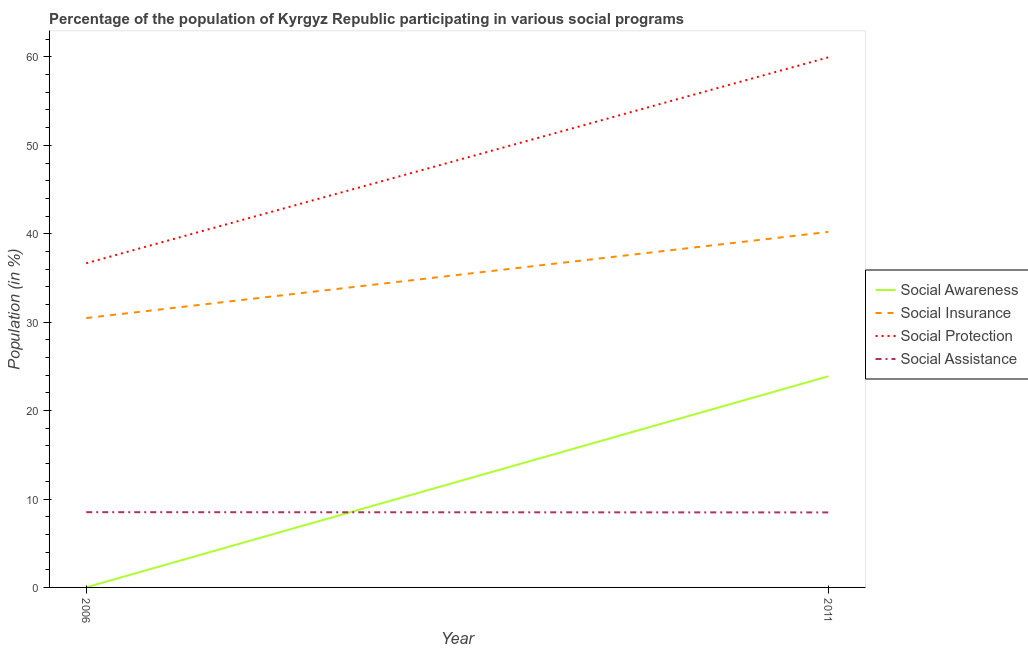How many different coloured lines are there?
Your response must be concise. 4. Does the line corresponding to participation of population in social assistance programs intersect with the line corresponding to participation of population in social protection programs?
Provide a short and direct response. No. What is the participation of population in social awareness programs in 2006?
Ensure brevity in your answer.  0.02. Across all years, what is the maximum participation of population in social insurance programs?
Offer a very short reply. 40.21. Across all years, what is the minimum participation of population in social insurance programs?
Your answer should be very brief. 30.47. In which year was the participation of population in social awareness programs maximum?
Offer a terse response. 2011. What is the total participation of population in social insurance programs in the graph?
Keep it short and to the point. 70.67. What is the difference between the participation of population in social insurance programs in 2006 and that in 2011?
Make the answer very short. -9.74. What is the difference between the participation of population in social insurance programs in 2011 and the participation of population in social awareness programs in 2006?
Your answer should be very brief. 40.19. What is the average participation of population in social assistance programs per year?
Provide a short and direct response. 8.5. In the year 2011, what is the difference between the participation of population in social insurance programs and participation of population in social protection programs?
Make the answer very short. -19.75. In how many years, is the participation of population in social insurance programs greater than 4 %?
Make the answer very short. 2. What is the ratio of the participation of population in social assistance programs in 2006 to that in 2011?
Keep it short and to the point. 1. Is the participation of population in social protection programs in 2006 less than that in 2011?
Provide a succinct answer. Yes. Does the participation of population in social awareness programs monotonically increase over the years?
Your answer should be very brief. Yes. Is the participation of population in social protection programs strictly greater than the participation of population in social insurance programs over the years?
Your answer should be compact. Yes. Is the participation of population in social awareness programs strictly less than the participation of population in social assistance programs over the years?
Give a very brief answer. No. What is the difference between two consecutive major ticks on the Y-axis?
Your answer should be compact. 10. Does the graph contain grids?
Provide a succinct answer. No. Where does the legend appear in the graph?
Make the answer very short. Center right. How are the legend labels stacked?
Ensure brevity in your answer.  Vertical. What is the title of the graph?
Your response must be concise. Percentage of the population of Kyrgyz Republic participating in various social programs . What is the label or title of the Y-axis?
Your response must be concise. Population (in %). What is the Population (in %) of Social Awareness in 2006?
Offer a terse response. 0.02. What is the Population (in %) of Social Insurance in 2006?
Provide a succinct answer. 30.47. What is the Population (in %) of Social Protection in 2006?
Offer a very short reply. 36.66. What is the Population (in %) in Social Assistance in 2006?
Offer a very short reply. 8.51. What is the Population (in %) in Social Awareness in 2011?
Keep it short and to the point. 23.88. What is the Population (in %) in Social Insurance in 2011?
Offer a terse response. 40.21. What is the Population (in %) in Social Protection in 2011?
Give a very brief answer. 59.95. What is the Population (in %) in Social Assistance in 2011?
Your answer should be compact. 8.48. Across all years, what is the maximum Population (in %) of Social Awareness?
Give a very brief answer. 23.88. Across all years, what is the maximum Population (in %) of Social Insurance?
Offer a very short reply. 40.21. Across all years, what is the maximum Population (in %) of Social Protection?
Give a very brief answer. 59.95. Across all years, what is the maximum Population (in %) of Social Assistance?
Provide a succinct answer. 8.51. Across all years, what is the minimum Population (in %) in Social Awareness?
Your answer should be compact. 0.02. Across all years, what is the minimum Population (in %) in Social Insurance?
Give a very brief answer. 30.47. Across all years, what is the minimum Population (in %) of Social Protection?
Ensure brevity in your answer.  36.66. Across all years, what is the minimum Population (in %) in Social Assistance?
Keep it short and to the point. 8.48. What is the total Population (in %) in Social Awareness in the graph?
Your answer should be very brief. 23.9. What is the total Population (in %) in Social Insurance in the graph?
Your answer should be very brief. 70.67. What is the total Population (in %) in Social Protection in the graph?
Provide a succinct answer. 96.62. What is the total Population (in %) in Social Assistance in the graph?
Your answer should be compact. 16.99. What is the difference between the Population (in %) of Social Awareness in 2006 and that in 2011?
Your answer should be very brief. -23.87. What is the difference between the Population (in %) in Social Insurance in 2006 and that in 2011?
Your answer should be compact. -9.74. What is the difference between the Population (in %) of Social Protection in 2006 and that in 2011?
Make the answer very short. -23.29. What is the difference between the Population (in %) in Social Assistance in 2006 and that in 2011?
Give a very brief answer. 0.03. What is the difference between the Population (in %) of Social Awareness in 2006 and the Population (in %) of Social Insurance in 2011?
Your answer should be very brief. -40.19. What is the difference between the Population (in %) in Social Awareness in 2006 and the Population (in %) in Social Protection in 2011?
Provide a short and direct response. -59.94. What is the difference between the Population (in %) in Social Awareness in 2006 and the Population (in %) in Social Assistance in 2011?
Offer a very short reply. -8.47. What is the difference between the Population (in %) of Social Insurance in 2006 and the Population (in %) of Social Protection in 2011?
Your response must be concise. -29.49. What is the difference between the Population (in %) in Social Insurance in 2006 and the Population (in %) in Social Assistance in 2011?
Your response must be concise. 21.98. What is the difference between the Population (in %) in Social Protection in 2006 and the Population (in %) in Social Assistance in 2011?
Offer a terse response. 28.18. What is the average Population (in %) of Social Awareness per year?
Your answer should be very brief. 11.95. What is the average Population (in %) in Social Insurance per year?
Provide a succinct answer. 35.34. What is the average Population (in %) of Social Protection per year?
Offer a terse response. 48.31. What is the average Population (in %) of Social Assistance per year?
Provide a succinct answer. 8.5. In the year 2006, what is the difference between the Population (in %) in Social Awareness and Population (in %) in Social Insurance?
Ensure brevity in your answer.  -30.45. In the year 2006, what is the difference between the Population (in %) in Social Awareness and Population (in %) in Social Protection?
Your response must be concise. -36.65. In the year 2006, what is the difference between the Population (in %) in Social Awareness and Population (in %) in Social Assistance?
Provide a short and direct response. -8.5. In the year 2006, what is the difference between the Population (in %) in Social Insurance and Population (in %) in Social Protection?
Offer a very short reply. -6.2. In the year 2006, what is the difference between the Population (in %) in Social Insurance and Population (in %) in Social Assistance?
Your response must be concise. 21.96. In the year 2006, what is the difference between the Population (in %) in Social Protection and Population (in %) in Social Assistance?
Your answer should be very brief. 28.15. In the year 2011, what is the difference between the Population (in %) of Social Awareness and Population (in %) of Social Insurance?
Your answer should be very brief. -16.33. In the year 2011, what is the difference between the Population (in %) of Social Awareness and Population (in %) of Social Protection?
Your response must be concise. -36.07. In the year 2011, what is the difference between the Population (in %) in Social Awareness and Population (in %) in Social Assistance?
Your response must be concise. 15.4. In the year 2011, what is the difference between the Population (in %) in Social Insurance and Population (in %) in Social Protection?
Provide a short and direct response. -19.75. In the year 2011, what is the difference between the Population (in %) in Social Insurance and Population (in %) in Social Assistance?
Offer a terse response. 31.73. In the year 2011, what is the difference between the Population (in %) of Social Protection and Population (in %) of Social Assistance?
Provide a short and direct response. 51.47. What is the ratio of the Population (in %) in Social Awareness in 2006 to that in 2011?
Provide a short and direct response. 0. What is the ratio of the Population (in %) in Social Insurance in 2006 to that in 2011?
Your response must be concise. 0.76. What is the ratio of the Population (in %) in Social Protection in 2006 to that in 2011?
Your answer should be compact. 0.61. What is the ratio of the Population (in %) in Social Assistance in 2006 to that in 2011?
Keep it short and to the point. 1. What is the difference between the highest and the second highest Population (in %) of Social Awareness?
Your response must be concise. 23.87. What is the difference between the highest and the second highest Population (in %) of Social Insurance?
Provide a short and direct response. 9.74. What is the difference between the highest and the second highest Population (in %) of Social Protection?
Make the answer very short. 23.29. What is the difference between the highest and the second highest Population (in %) in Social Assistance?
Ensure brevity in your answer.  0.03. What is the difference between the highest and the lowest Population (in %) in Social Awareness?
Your response must be concise. 23.87. What is the difference between the highest and the lowest Population (in %) of Social Insurance?
Offer a very short reply. 9.74. What is the difference between the highest and the lowest Population (in %) of Social Protection?
Make the answer very short. 23.29. What is the difference between the highest and the lowest Population (in %) in Social Assistance?
Your answer should be very brief. 0.03. 